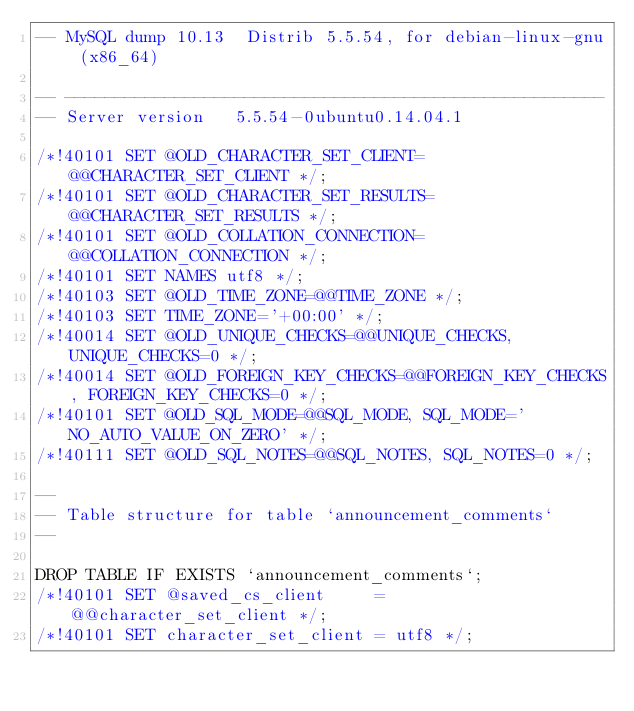Convert code to text. <code><loc_0><loc_0><loc_500><loc_500><_SQL_>-- MySQL dump 10.13  Distrib 5.5.54, for debian-linux-gnu (x86_64)

-- ------------------------------------------------------
-- Server version	5.5.54-0ubuntu0.14.04.1

/*!40101 SET @OLD_CHARACTER_SET_CLIENT=@@CHARACTER_SET_CLIENT */;
/*!40101 SET @OLD_CHARACTER_SET_RESULTS=@@CHARACTER_SET_RESULTS */;
/*!40101 SET @OLD_COLLATION_CONNECTION=@@COLLATION_CONNECTION */;
/*!40101 SET NAMES utf8 */;
/*!40103 SET @OLD_TIME_ZONE=@@TIME_ZONE */;
/*!40103 SET TIME_ZONE='+00:00' */;
/*!40014 SET @OLD_UNIQUE_CHECKS=@@UNIQUE_CHECKS, UNIQUE_CHECKS=0 */;
/*!40014 SET @OLD_FOREIGN_KEY_CHECKS=@@FOREIGN_KEY_CHECKS, FOREIGN_KEY_CHECKS=0 */;
/*!40101 SET @OLD_SQL_MODE=@@SQL_MODE, SQL_MODE='NO_AUTO_VALUE_ON_ZERO' */;
/*!40111 SET @OLD_SQL_NOTES=@@SQL_NOTES, SQL_NOTES=0 */;

--
-- Table structure for table `announcement_comments`
--

DROP TABLE IF EXISTS `announcement_comments`;
/*!40101 SET @saved_cs_client     = @@character_set_client */;
/*!40101 SET character_set_client = utf8 */;</code> 